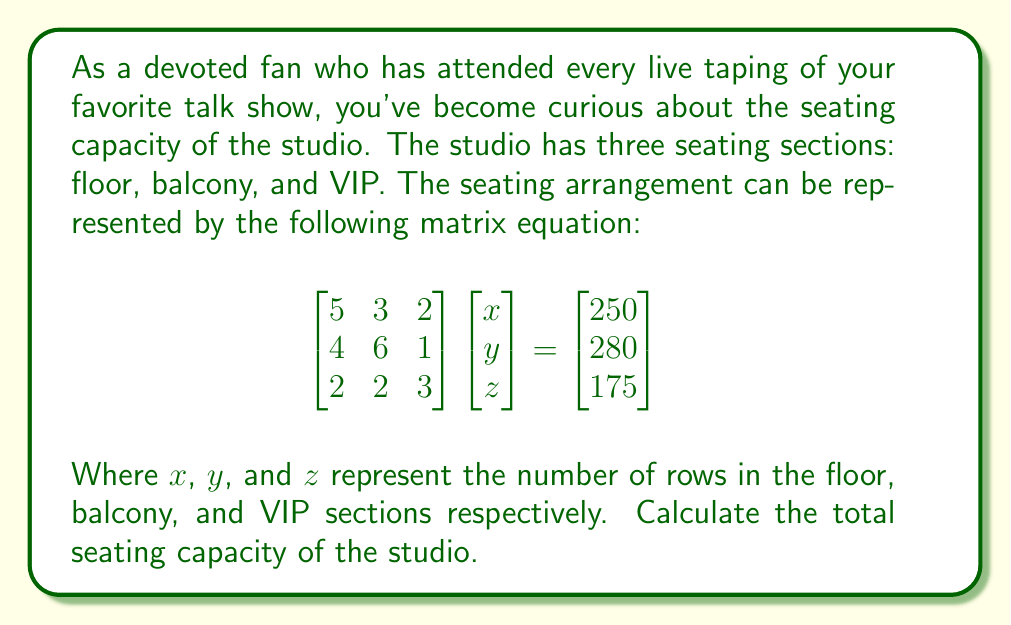Give your solution to this math problem. To solve this problem, we need to follow these steps:

1) First, we need to solve the matrix equation to find the values of $x$, $y$, and $z$. We can do this using Cramer's rule or matrix inversion.

2) Using matrix inversion:
   Let $A = \begin{bmatrix} 
   5 & 3 & 2 \\
   4 & 6 & 1 \\
   2 & 2 & 3
   \end{bmatrix}$ and $b = \begin{bmatrix}
   250 \\ 280 \\ 175
   \end{bmatrix}$

3) We need to find $A^{-1}$:
   $$A^{-1} = \frac{1}{det(A)} \begin{bmatrix}
   51 & -13 & -22 \\
   -24 & 21 & 6 \\
   -6 & -9 & 24
   \end{bmatrix}$$
   where $det(A) = 78$

4) Now we can solve for $\begin{bmatrix} x \\ y \\ z \end{bmatrix} = A^{-1}b$:

   $$\begin{bmatrix} x \\ y \\ z \end{bmatrix} = \frac{1}{78} \begin{bmatrix}
   51 & -13 & -22 \\
   -24 & 21 & 6 \\
   -6 & -9 & 24
   \end{bmatrix} \begin{bmatrix}
   250 \\ 280 \\ 175
   \end{bmatrix}$$

5) Multiplying these matrices:
   $$\begin{bmatrix} x \\ y \\ z \end{bmatrix} = \begin{bmatrix}
   30 \\ 20 \\ 25
   \end{bmatrix}$$

6) Now that we know the number of rows in each section, we need to calculate the number of seats in each row:
   - Floor section: $5x + 3y + 2z = 250$
   - Balcony section: $4x + 6y + z = 280$
   - VIP section: $2x + 2y + 3z = 175$

7) Substituting the values we found:
   - Floor: $5(30) + 3(20) + 2(25) = 250$ seats
   - Balcony: $4(30) + 6(20) + 1(25) = 265$ seats
   - VIP: $2(30) + 2(20) + 3(25) = 175$ seats

8) The total seating capacity is the sum of all these sections:
   $250 + 265 + 175 = 690$ seats
Answer: The total seating capacity of the talk show studio is 690 seats. 